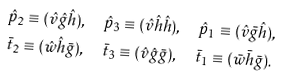Convert formula to latex. <formula><loc_0><loc_0><loc_500><loc_500>& \hat { p } _ { 2 } \equiv ( \hat { v } \hat { g } \hat { h } ) , \quad \hat { p } _ { 3 } \equiv ( \hat { v } \hat { h } \hat { h } ) , \quad \hat { p } _ { 1 } \equiv ( \hat { v } \bar { g } \hat { h } ) , \\ & \bar { t } _ { 2 } \equiv ( \hat { w } \hat { h } \bar { g } ) , \quad \bar { t } _ { 3 } \equiv ( \hat { v } \hat { g } \bar { g } ) , \quad \bar { t } _ { 1 } \equiv ( \bar { w } \bar { h } \bar { g } ) .</formula> 